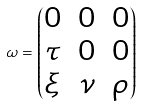<formula> <loc_0><loc_0><loc_500><loc_500>\omega = \begin{pmatrix} 0 & 0 & 0 \\ \tau & 0 & 0 \\ \xi & \nu & \rho \end{pmatrix}</formula> 